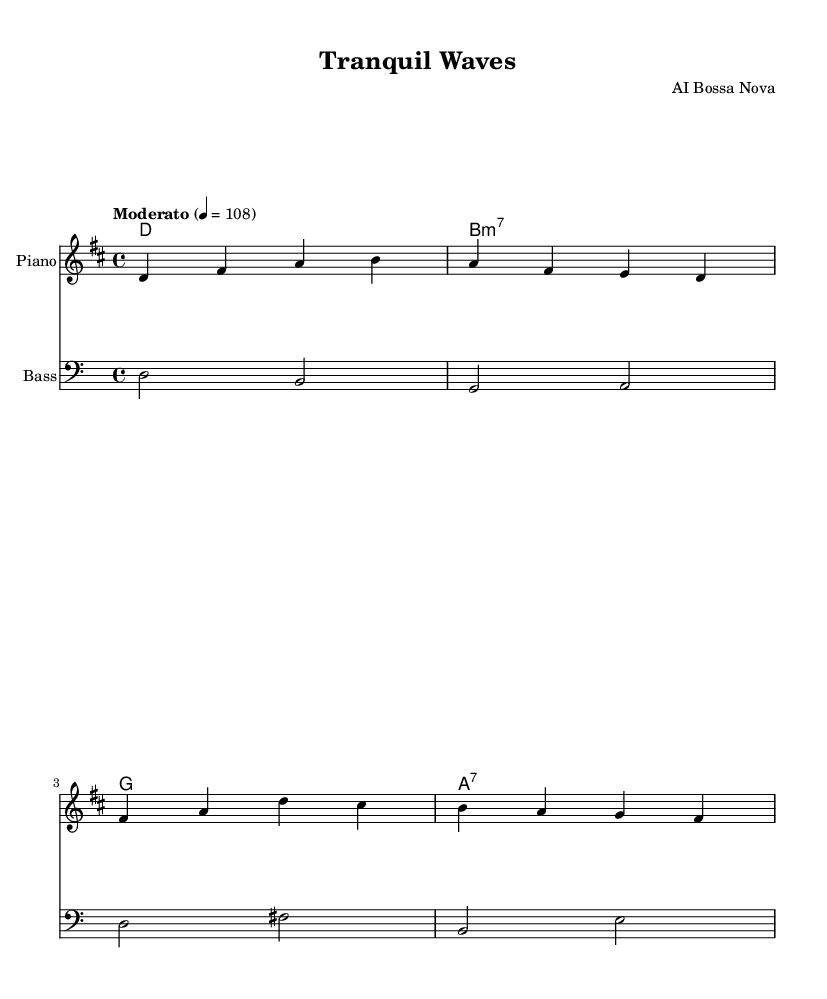What is the key signature of this music? The key signature is D major, which has two sharps (F# and C#). This is indicated at the beginning of the staff.
Answer: D major What is the time signature of this piece? The time signature is 4/4, which is indicated at the beginning of the music and shows that there are four beats in each measure.
Answer: 4/4 What is the tempo marking for this piece? The tempo marking is "Moderato," which suggests a moderate pace for the performance. The specific metronome marking is 108 beats per minute.
Answer: Moderato How many measures are in the melody? There are four measures in the melody, which can be counted by looking at the vertical lines that separate each measure.
Answer: 4 What is the first note of the melody? The first note of the melody is D, found in the first measure. This note is positioned on the second line of the staff.
Answer: D What chords are used in the harmonies section? The chords used in the harmonies section are D, B minor 7, G, and A7. Each chord is represented above the staff with chord symbols.
Answer: D, B minor 7, G, A7 What type of bass clef is used in this piece? The bass line uses the standard bass clef, which is indicated at the beginning of the bass staff. The notes are positioned below the treble staff.
Answer: Standard bass clef 